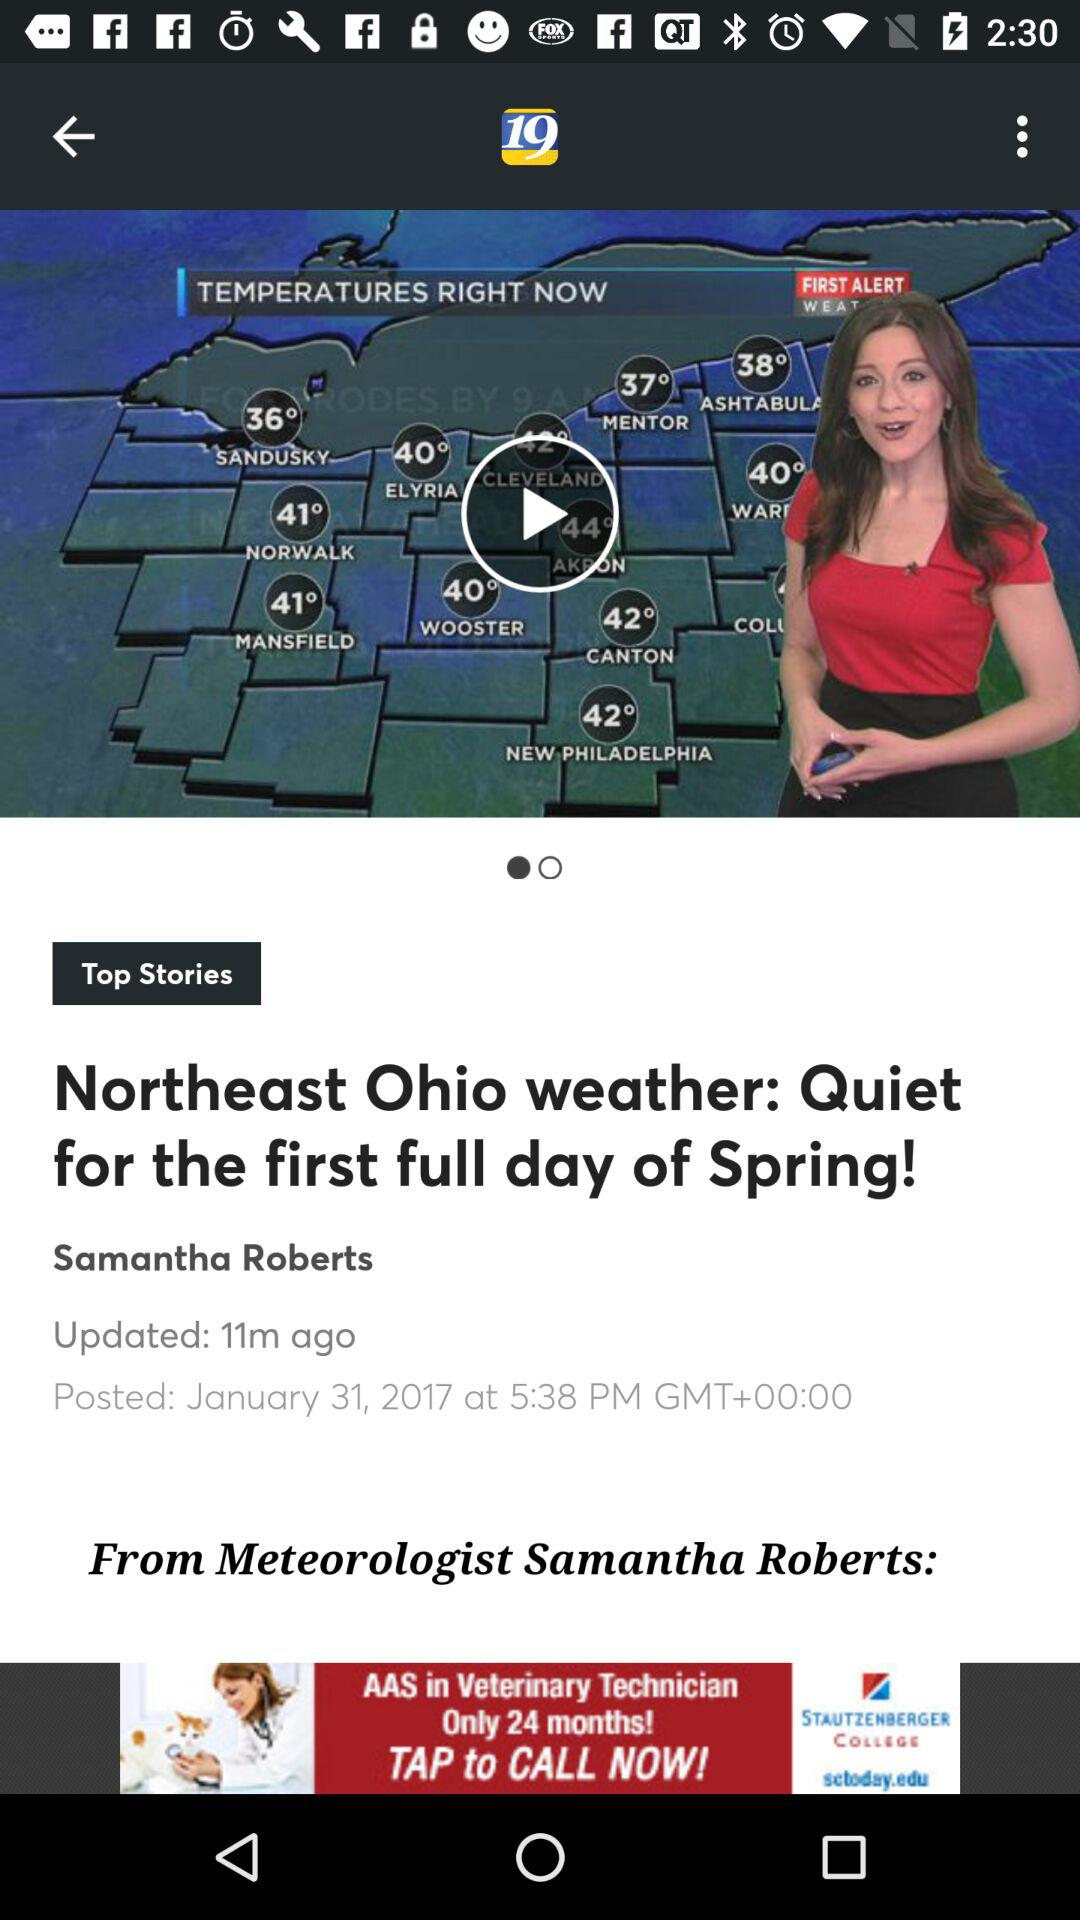At what time did Samantha Roberts update the news? The news was updated 11 minutes ago. 